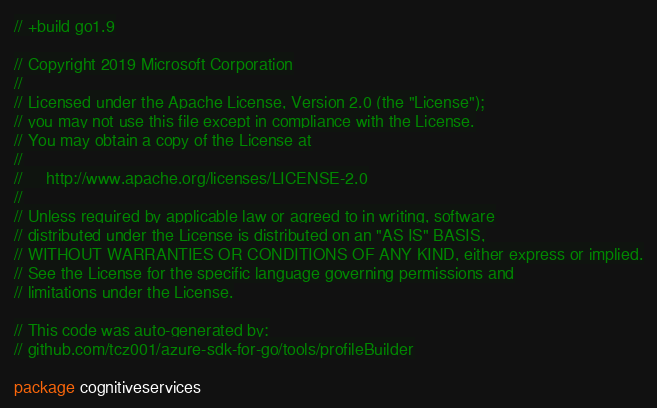Convert code to text. <code><loc_0><loc_0><loc_500><loc_500><_Go_>// +build go1.9

// Copyright 2019 Microsoft Corporation
//
// Licensed under the Apache License, Version 2.0 (the "License");
// you may not use this file except in compliance with the License.
// You may obtain a copy of the License at
//
//     http://www.apache.org/licenses/LICENSE-2.0
//
// Unless required by applicable law or agreed to in writing, software
// distributed under the License is distributed on an "AS IS" BASIS,
// WITHOUT WARRANTIES OR CONDITIONS OF ANY KIND, either express or implied.
// See the License for the specific language governing permissions and
// limitations under the License.

// This code was auto-generated by:
// github.com/tcz001/azure-sdk-for-go/tools/profileBuilder

package cognitiveservices
</code> 